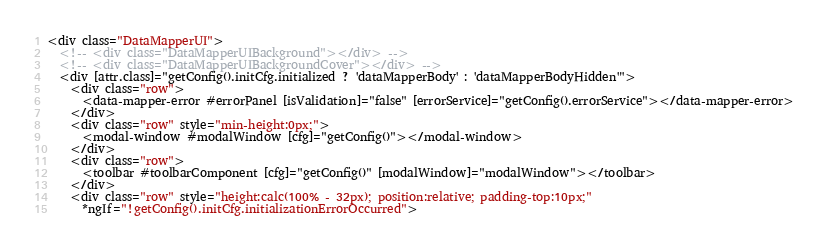<code> <loc_0><loc_0><loc_500><loc_500><_HTML_><div class="DataMapperUI">
  <!-- <div class="DataMapperUIBackground"></div> -->
  <!-- <div class="DataMapperUIBackgroundCover"></div> -->
  <div [attr.class]="getConfig().initCfg.initialized ? 'dataMapperBody' : 'dataMapperBodyHidden'">
    <div class="row">
      <data-mapper-error #errorPanel [isValidation]="false" [errorService]="getConfig().errorService"></data-mapper-error>
    </div>
    <div class="row" style="min-height:0px;">
      <modal-window #modalWindow [cfg]="getConfig()"></modal-window>
    </div>
    <div class="row">
      <toolbar #toolbarComponent [cfg]="getConfig()" [modalWindow]="modalWindow"></toolbar>
    </div>
    <div class="row" style="height:calc(100% - 32px); position:relative; padding-top:10px;"
      *ngIf="!getConfig().initCfg.initializationErrorOccurred"></code> 